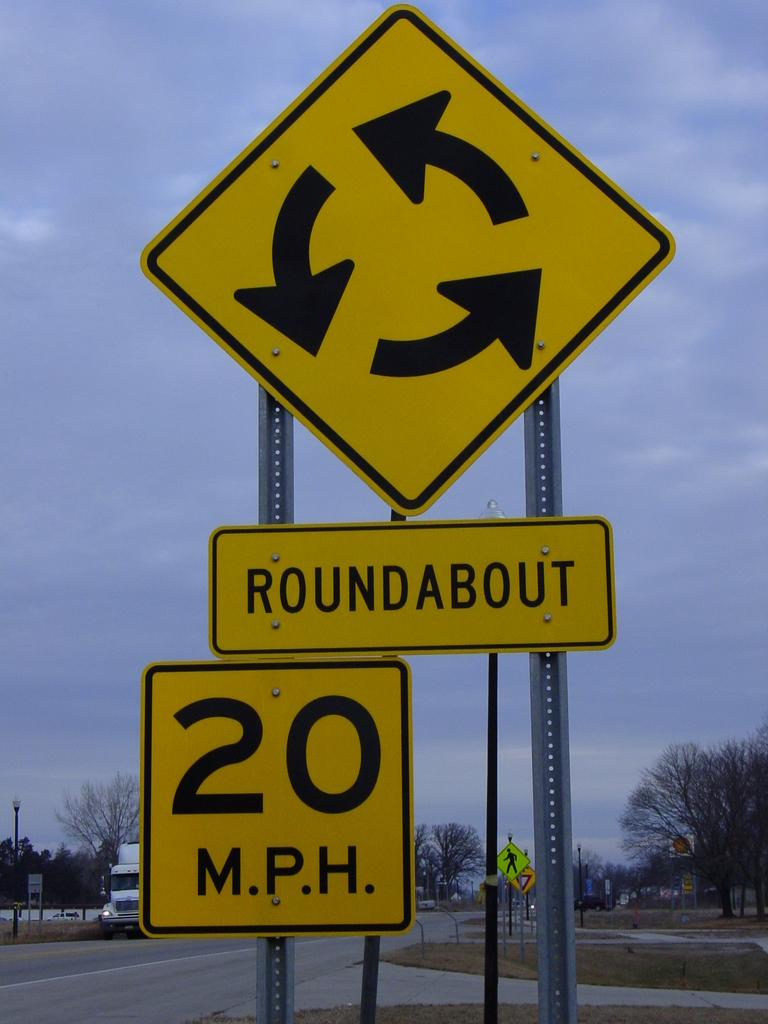<image>
Render a clear and concise summary of the photo. A yellow and black sign that says Roundabout and 20mph 